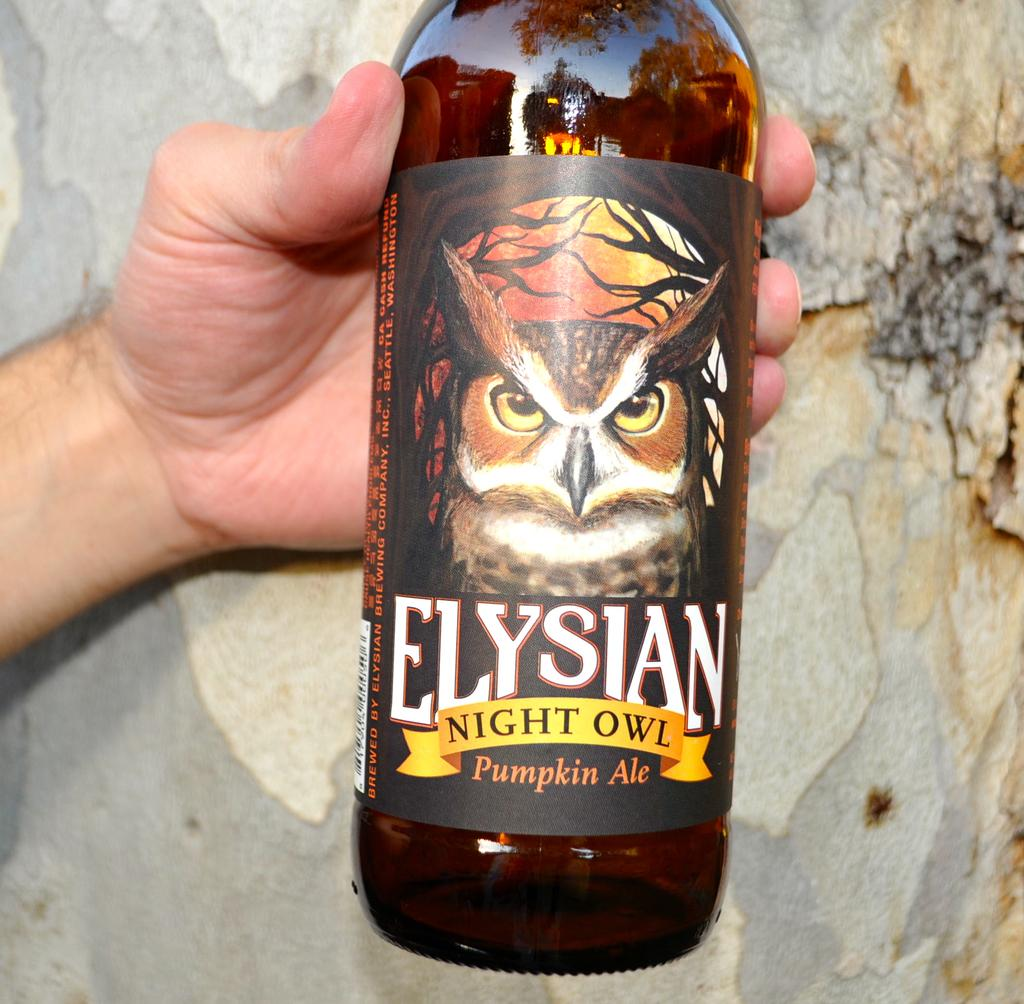Provide a one-sentence caption for the provided image. A bottle of Elysian Night Owl Pumpkin Ale being held in a hand. 